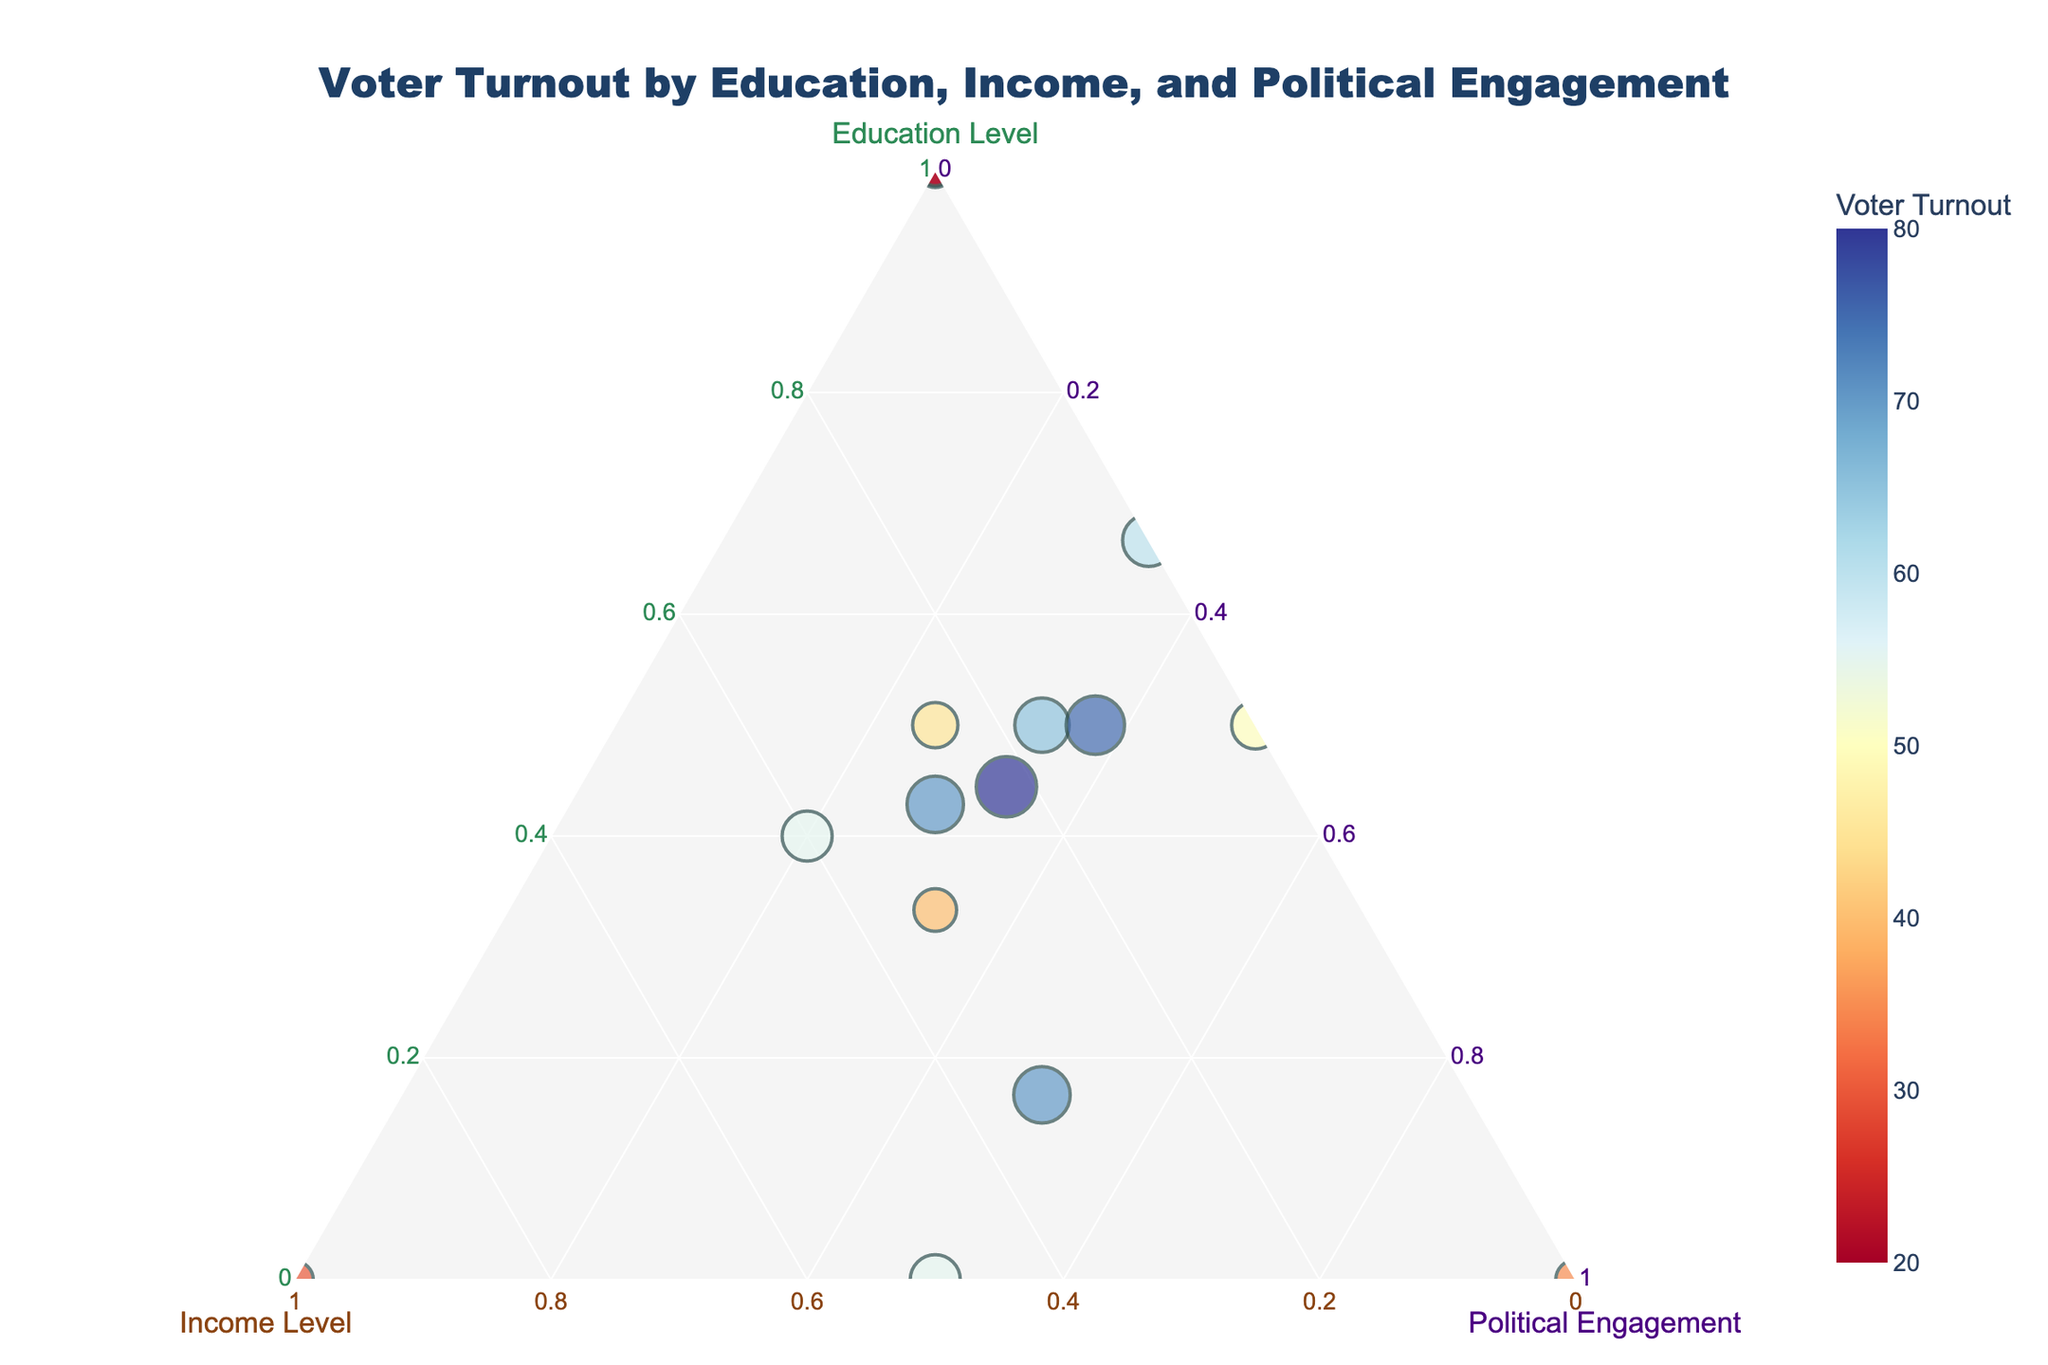What is the title of the figure? The title is displayed at the top of the figure. It reads "Voter Turnout by Education, Income, and Political Engagement."
Answer: Voter Turnout by Education, Income, and Political Engagement Which axis represents the Education Level? In a ternary plot, axes are not typical linear axes. However, the axis labeled with “Education Level” is the one to focus on for education values.
Answer: The axis labeled 'Education Level' How many data points are represented in the plot? By counting the number of distinct markers in the plot, you can identify the total number of data points.
Answer: 15 Which data point has the highest Voter Turnout? In the plot, the marker with the largest size represents the data point with the highest Voter Turnout. The color scale can also guide you by showing the highest value in its legend.
Answer: The Graduate level with High Income and Very High Political Engagement How does the Voter Turnout vary for individuals with a High School education across different income levels? By examining the positions and sizes of the markers designated for "High School", one can compare Voter Turnout across "Low", "Medium", and "High" income levels.
Answer: Voter Turnout ranges from 30 to 55 What is the median Voter Turnout across all data points? To calculate the median, sort all Voter Turnout values and find the middle value. The values in ascending order are: 20, 25, 30, 35, 40, 45, 50, 55, 55, 60, 65, 70, 70, 75, 80. The middle value (8th) in this sorted list is 55.
Answer: 55 Which Education Level contributes the most to total Voter Turnout? Sum the turnout values corresponding to each Education Level and compare the sums.
Answer: Graduate level Compare the Voter Turnout for individuals with a Bachelor's degree and Medium income versus those with a Bachelor's degree and High income. Examine the plot markers for a Bachelor's degree (coded appropriately), focusing on medium and high income conditions. Compare the sizes and colors of these markers.
Answer: Medium income: 65, High income: 70 What combination of Education Level, Income Level, and Political Engagement shows the lowest Voter Turnout? Identify the smallest marker (in terms of size and/or color intensity indicating the lowest turnout value) in the plot to determine this combination.
Answer: Bachelor's degree, Low income, Low Political Engagement Which axis shows the highest coding value, Education Level, Income Level, or Political Engagement? Examine the plot where each axis represents one of these metrics and observe which axis has the largest range of values shown.
Answer: Political Engagement 